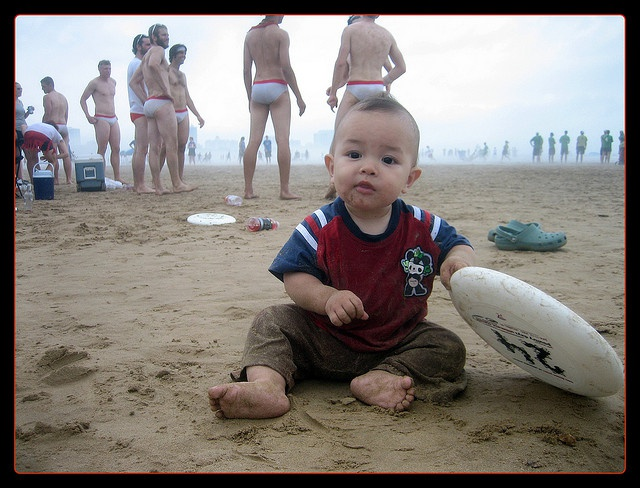Describe the objects in this image and their specific colors. I can see people in black, gray, and darkgray tones, frisbee in black, gray, darkgray, and lightgray tones, people in black, darkgray, gray, and white tones, people in black, darkgray, and gray tones, and people in black, darkgray, gray, and white tones in this image. 